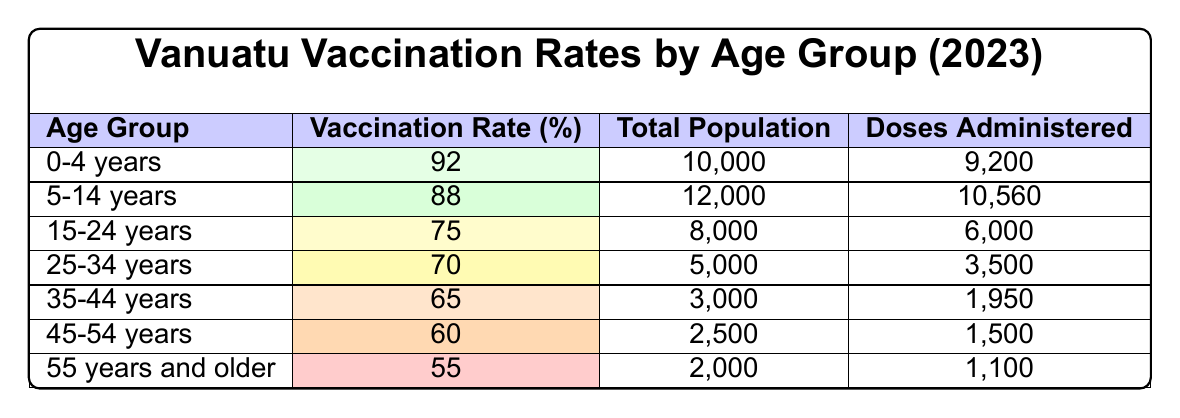What is the vaccination rate for the age group 35-44 years? The table shows that the vaccination rate for the age group 35-44 years is 65%.
Answer: 65% Which age group has the highest total population? From the table, the age group with the highest total population is 5-14 years with 12,000 people.
Answer: 5-14 years How many doses were administered to the age group 25-34 years? According to the table, a total of 3,500 doses were administered to the 25-34 years age group.
Answer: 3,500 What is the difference in vaccination rates between the 0-4 years and 55 years and older age groups? The vaccination rate for the 0-4 years age group is 92%, and for 55 years and older, it is 55%. The difference is 92 - 55 = 37%.
Answer: 37% Is the vaccination rate for the 15-24 years age group higher than 70%? The vaccination rate for the 15-24 years age group is 75%, which is higher than 70%. Therefore, the statement is true.
Answer: Yes What is the average vaccination rate across all age groups? To find the average, we sum the vaccination rates: (92 + 88 + 75 + 70 + 65 + 60 + 55) = 505. There are 7 age groups, so the average is 505 / 7 ≈ 72.14%.
Answer: 72.14% How many more doses were administered to the 0-4 years age group compared to the 45-54 years age group? The 0-4 years age group received 9,200 doses, while the 45-54 years age group received 1,500 doses. The difference is 9,200 - 1,500 = 7,700 doses.
Answer: 7,700 Which age group has the lowest vaccination rate and what is that rate? The age group with the lowest vaccination rate is 55 years and older, with a rate of 55%.
Answer: 55% What percentage of the population in the 15-24 years age group was vaccinated? The vaccination rate for the 15-24 years age group is 75%, which means that 75% of the total population in that group was vaccinated.
Answer: 75% 